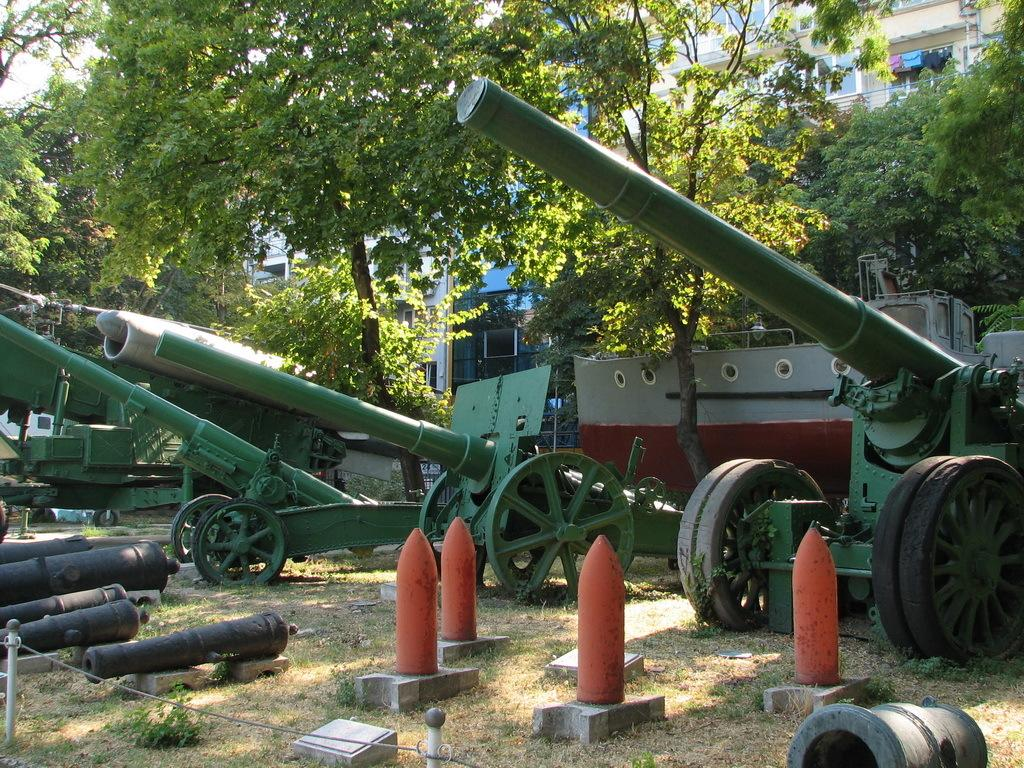What type of objects are present in the image? There are cannons in the image. What is the color of the cannons? The cannons are green. What other colorful objects can be seen in the image? There are orange color poles and black color pipes visible in the image. What can be seen in the background of the image? There is a building, glass windows, and trees visible in the background. Where is the cobweb located in the image? There is no cobweb present in the image. What type of thread is used to create the cannons in the image? The cannons in the image are not made of thread; they are likely made of metal or another solid material. 